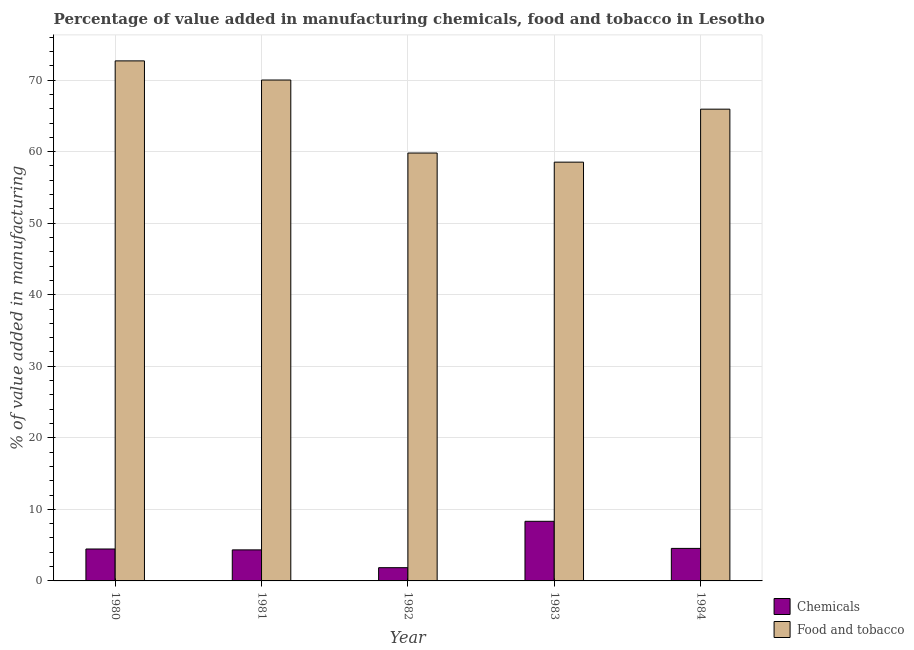How many groups of bars are there?
Make the answer very short. 5. Are the number of bars per tick equal to the number of legend labels?
Offer a terse response. Yes. Are the number of bars on each tick of the X-axis equal?
Make the answer very short. Yes. How many bars are there on the 5th tick from the right?
Your response must be concise. 2. What is the label of the 4th group of bars from the left?
Your answer should be compact. 1983. In how many cases, is the number of bars for a given year not equal to the number of legend labels?
Make the answer very short. 0. What is the value added by  manufacturing chemicals in 1984?
Give a very brief answer. 4.55. Across all years, what is the maximum value added by  manufacturing chemicals?
Offer a terse response. 8.33. Across all years, what is the minimum value added by  manufacturing chemicals?
Keep it short and to the point. 1.85. In which year was the value added by manufacturing food and tobacco minimum?
Your answer should be very brief. 1983. What is the total value added by  manufacturing chemicals in the graph?
Give a very brief answer. 23.53. What is the difference between the value added by manufacturing food and tobacco in 1980 and that in 1983?
Ensure brevity in your answer.  14.15. What is the difference between the value added by manufacturing food and tobacco in 1980 and the value added by  manufacturing chemicals in 1983?
Your answer should be compact. 14.15. What is the average value added by manufacturing food and tobacco per year?
Offer a very short reply. 65.39. In the year 1983, what is the difference between the value added by  manufacturing chemicals and value added by manufacturing food and tobacco?
Your response must be concise. 0. What is the ratio of the value added by  manufacturing chemicals in 1980 to that in 1984?
Make the answer very short. 0.98. What is the difference between the highest and the second highest value added by  manufacturing chemicals?
Ensure brevity in your answer.  3.79. What is the difference between the highest and the lowest value added by manufacturing food and tobacco?
Your answer should be very brief. 14.15. Is the sum of the value added by manufacturing food and tobacco in 1981 and 1982 greater than the maximum value added by  manufacturing chemicals across all years?
Provide a short and direct response. Yes. What does the 2nd bar from the left in 1981 represents?
Your answer should be very brief. Food and tobacco. What does the 1st bar from the right in 1980 represents?
Provide a short and direct response. Food and tobacco. How many bars are there?
Provide a short and direct response. 10. How many years are there in the graph?
Provide a succinct answer. 5. What is the difference between two consecutive major ticks on the Y-axis?
Provide a short and direct response. 10. Are the values on the major ticks of Y-axis written in scientific E-notation?
Offer a very short reply. No. Does the graph contain any zero values?
Keep it short and to the point. No. Does the graph contain grids?
Give a very brief answer. Yes. Where does the legend appear in the graph?
Offer a very short reply. Bottom right. How are the legend labels stacked?
Provide a succinct answer. Vertical. What is the title of the graph?
Make the answer very short. Percentage of value added in manufacturing chemicals, food and tobacco in Lesotho. Does "Number of departures" appear as one of the legend labels in the graph?
Provide a succinct answer. No. What is the label or title of the Y-axis?
Make the answer very short. % of value added in manufacturing. What is the % of value added in manufacturing of Chemicals in 1980?
Provide a short and direct response. 4.46. What is the % of value added in manufacturing in Food and tobacco in 1980?
Make the answer very short. 72.68. What is the % of value added in manufacturing in Chemicals in 1981?
Make the answer very short. 4.34. What is the % of value added in manufacturing in Food and tobacco in 1981?
Offer a terse response. 70.01. What is the % of value added in manufacturing in Chemicals in 1982?
Your response must be concise. 1.85. What is the % of value added in manufacturing in Food and tobacco in 1982?
Give a very brief answer. 59.81. What is the % of value added in manufacturing of Chemicals in 1983?
Your response must be concise. 8.33. What is the % of value added in manufacturing in Food and tobacco in 1983?
Offer a very short reply. 58.53. What is the % of value added in manufacturing in Chemicals in 1984?
Your answer should be very brief. 4.55. What is the % of value added in manufacturing of Food and tobacco in 1984?
Offer a terse response. 65.93. Across all years, what is the maximum % of value added in manufacturing of Chemicals?
Make the answer very short. 8.33. Across all years, what is the maximum % of value added in manufacturing of Food and tobacco?
Provide a succinct answer. 72.68. Across all years, what is the minimum % of value added in manufacturing of Chemicals?
Ensure brevity in your answer.  1.85. Across all years, what is the minimum % of value added in manufacturing of Food and tobacco?
Provide a succinct answer. 58.53. What is the total % of value added in manufacturing in Chemicals in the graph?
Your answer should be compact. 23.53. What is the total % of value added in manufacturing of Food and tobacco in the graph?
Offer a terse response. 326.96. What is the difference between the % of value added in manufacturing of Chemicals in 1980 and that in 1981?
Give a very brief answer. 0.12. What is the difference between the % of value added in manufacturing of Food and tobacco in 1980 and that in 1981?
Keep it short and to the point. 2.68. What is the difference between the % of value added in manufacturing in Chemicals in 1980 and that in 1982?
Provide a short and direct response. 2.61. What is the difference between the % of value added in manufacturing of Food and tobacco in 1980 and that in 1982?
Your response must be concise. 12.88. What is the difference between the % of value added in manufacturing of Chemicals in 1980 and that in 1983?
Your response must be concise. -3.87. What is the difference between the % of value added in manufacturing of Food and tobacco in 1980 and that in 1983?
Your answer should be very brief. 14.15. What is the difference between the % of value added in manufacturing of Chemicals in 1980 and that in 1984?
Offer a very short reply. -0.08. What is the difference between the % of value added in manufacturing in Food and tobacco in 1980 and that in 1984?
Ensure brevity in your answer.  6.75. What is the difference between the % of value added in manufacturing of Chemicals in 1981 and that in 1982?
Keep it short and to the point. 2.49. What is the difference between the % of value added in manufacturing of Food and tobacco in 1981 and that in 1982?
Your answer should be very brief. 10.2. What is the difference between the % of value added in manufacturing of Chemicals in 1981 and that in 1983?
Provide a succinct answer. -3.99. What is the difference between the % of value added in manufacturing in Food and tobacco in 1981 and that in 1983?
Make the answer very short. 11.48. What is the difference between the % of value added in manufacturing of Chemicals in 1981 and that in 1984?
Offer a terse response. -0.21. What is the difference between the % of value added in manufacturing of Food and tobacco in 1981 and that in 1984?
Ensure brevity in your answer.  4.07. What is the difference between the % of value added in manufacturing in Chemicals in 1982 and that in 1983?
Your response must be concise. -6.48. What is the difference between the % of value added in manufacturing in Food and tobacco in 1982 and that in 1983?
Give a very brief answer. 1.28. What is the difference between the % of value added in manufacturing of Chemicals in 1982 and that in 1984?
Make the answer very short. -2.69. What is the difference between the % of value added in manufacturing of Food and tobacco in 1982 and that in 1984?
Provide a succinct answer. -6.13. What is the difference between the % of value added in manufacturing of Chemicals in 1983 and that in 1984?
Your response must be concise. 3.79. What is the difference between the % of value added in manufacturing of Food and tobacco in 1983 and that in 1984?
Your answer should be compact. -7.4. What is the difference between the % of value added in manufacturing of Chemicals in 1980 and the % of value added in manufacturing of Food and tobacco in 1981?
Your answer should be very brief. -65.54. What is the difference between the % of value added in manufacturing of Chemicals in 1980 and the % of value added in manufacturing of Food and tobacco in 1982?
Provide a short and direct response. -55.34. What is the difference between the % of value added in manufacturing in Chemicals in 1980 and the % of value added in manufacturing in Food and tobacco in 1983?
Your answer should be very brief. -54.07. What is the difference between the % of value added in manufacturing of Chemicals in 1980 and the % of value added in manufacturing of Food and tobacco in 1984?
Make the answer very short. -61.47. What is the difference between the % of value added in manufacturing of Chemicals in 1981 and the % of value added in manufacturing of Food and tobacco in 1982?
Provide a short and direct response. -55.47. What is the difference between the % of value added in manufacturing in Chemicals in 1981 and the % of value added in manufacturing in Food and tobacco in 1983?
Your answer should be compact. -54.19. What is the difference between the % of value added in manufacturing in Chemicals in 1981 and the % of value added in manufacturing in Food and tobacco in 1984?
Keep it short and to the point. -61.6. What is the difference between the % of value added in manufacturing of Chemicals in 1982 and the % of value added in manufacturing of Food and tobacco in 1983?
Your response must be concise. -56.68. What is the difference between the % of value added in manufacturing of Chemicals in 1982 and the % of value added in manufacturing of Food and tobacco in 1984?
Keep it short and to the point. -64.08. What is the difference between the % of value added in manufacturing in Chemicals in 1983 and the % of value added in manufacturing in Food and tobacco in 1984?
Keep it short and to the point. -57.6. What is the average % of value added in manufacturing in Chemicals per year?
Keep it short and to the point. 4.71. What is the average % of value added in manufacturing of Food and tobacco per year?
Make the answer very short. 65.39. In the year 1980, what is the difference between the % of value added in manufacturing in Chemicals and % of value added in manufacturing in Food and tobacco?
Make the answer very short. -68.22. In the year 1981, what is the difference between the % of value added in manufacturing in Chemicals and % of value added in manufacturing in Food and tobacco?
Provide a short and direct response. -65.67. In the year 1982, what is the difference between the % of value added in manufacturing of Chemicals and % of value added in manufacturing of Food and tobacco?
Offer a terse response. -57.95. In the year 1983, what is the difference between the % of value added in manufacturing of Chemicals and % of value added in manufacturing of Food and tobacco?
Ensure brevity in your answer.  -50.2. In the year 1984, what is the difference between the % of value added in manufacturing of Chemicals and % of value added in manufacturing of Food and tobacco?
Ensure brevity in your answer.  -61.39. What is the ratio of the % of value added in manufacturing in Chemicals in 1980 to that in 1981?
Your answer should be compact. 1.03. What is the ratio of the % of value added in manufacturing in Food and tobacco in 1980 to that in 1981?
Ensure brevity in your answer.  1.04. What is the ratio of the % of value added in manufacturing in Chemicals in 1980 to that in 1982?
Provide a succinct answer. 2.41. What is the ratio of the % of value added in manufacturing in Food and tobacco in 1980 to that in 1982?
Provide a succinct answer. 1.22. What is the ratio of the % of value added in manufacturing in Chemicals in 1980 to that in 1983?
Ensure brevity in your answer.  0.54. What is the ratio of the % of value added in manufacturing of Food and tobacco in 1980 to that in 1983?
Keep it short and to the point. 1.24. What is the ratio of the % of value added in manufacturing in Chemicals in 1980 to that in 1984?
Your answer should be very brief. 0.98. What is the ratio of the % of value added in manufacturing in Food and tobacco in 1980 to that in 1984?
Make the answer very short. 1.1. What is the ratio of the % of value added in manufacturing of Chemicals in 1981 to that in 1982?
Make the answer very short. 2.34. What is the ratio of the % of value added in manufacturing in Food and tobacco in 1981 to that in 1982?
Make the answer very short. 1.17. What is the ratio of the % of value added in manufacturing in Chemicals in 1981 to that in 1983?
Keep it short and to the point. 0.52. What is the ratio of the % of value added in manufacturing of Food and tobacco in 1981 to that in 1983?
Your answer should be very brief. 1.2. What is the ratio of the % of value added in manufacturing in Chemicals in 1981 to that in 1984?
Offer a very short reply. 0.95. What is the ratio of the % of value added in manufacturing of Food and tobacco in 1981 to that in 1984?
Your answer should be very brief. 1.06. What is the ratio of the % of value added in manufacturing of Chemicals in 1982 to that in 1983?
Provide a short and direct response. 0.22. What is the ratio of the % of value added in manufacturing of Food and tobacco in 1982 to that in 1983?
Ensure brevity in your answer.  1.02. What is the ratio of the % of value added in manufacturing in Chemicals in 1982 to that in 1984?
Give a very brief answer. 0.41. What is the ratio of the % of value added in manufacturing of Food and tobacco in 1982 to that in 1984?
Provide a short and direct response. 0.91. What is the ratio of the % of value added in manufacturing of Chemicals in 1983 to that in 1984?
Offer a very short reply. 1.83. What is the ratio of the % of value added in manufacturing in Food and tobacco in 1983 to that in 1984?
Give a very brief answer. 0.89. What is the difference between the highest and the second highest % of value added in manufacturing in Chemicals?
Your response must be concise. 3.79. What is the difference between the highest and the second highest % of value added in manufacturing of Food and tobacco?
Provide a succinct answer. 2.68. What is the difference between the highest and the lowest % of value added in manufacturing in Chemicals?
Ensure brevity in your answer.  6.48. What is the difference between the highest and the lowest % of value added in manufacturing in Food and tobacco?
Your response must be concise. 14.15. 